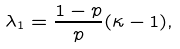<formula> <loc_0><loc_0><loc_500><loc_500>\lambda _ { 1 } = \frac { 1 - p } { p } ( \kappa - 1 ) ,</formula> 